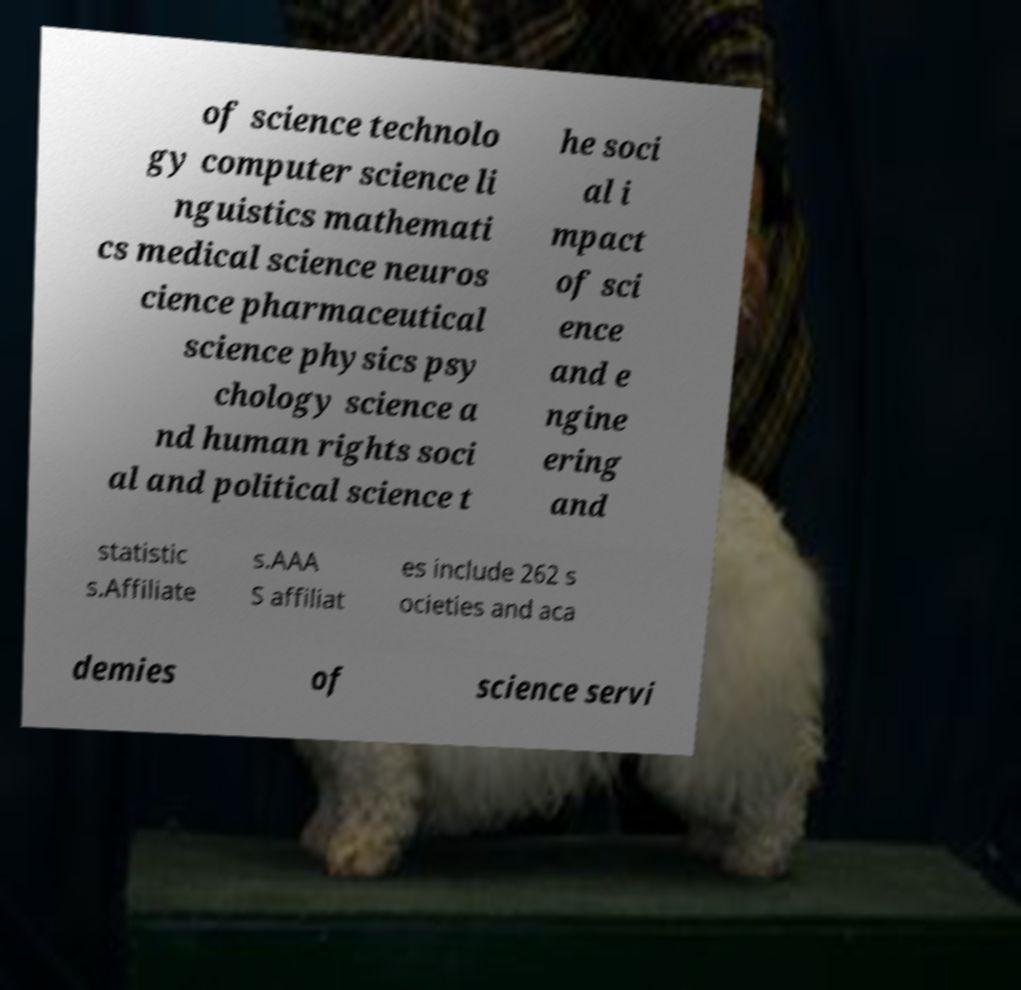Can you accurately transcribe the text from the provided image for me? of science technolo gy computer science li nguistics mathemati cs medical science neuros cience pharmaceutical science physics psy chology science a nd human rights soci al and political science t he soci al i mpact of sci ence and e ngine ering and statistic s.Affiliate s.AAA S affiliat es include 262 s ocieties and aca demies of science servi 